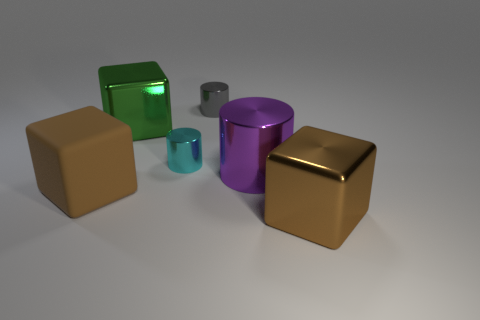Does the rubber cube have the same color as the big metal block that is to the right of the small gray metal object?
Provide a succinct answer. Yes. There is a tiny object in front of the big metallic cube that is to the left of the large brown block to the right of the gray metallic cylinder; what color is it?
Ensure brevity in your answer.  Cyan. Are there fewer big things that are in front of the large metallic cylinder than large brown cubes behind the brown rubber block?
Ensure brevity in your answer.  No. Is the shape of the green object the same as the large brown metal object?
Your answer should be compact. Yes. How many other objects are the same size as the purple shiny object?
Offer a very short reply. 3. Are there fewer tiny gray shiny cylinders that are in front of the purple thing than large matte objects?
Offer a terse response. Yes. What is the size of the green object that is to the left of the metallic cylinder behind the green shiny thing?
Your response must be concise. Large. How many things are either green blocks or big shiny objects?
Your answer should be very brief. 3. Are there any large cubes of the same color as the rubber object?
Offer a terse response. Yes. Is the number of big purple metallic things less than the number of metal blocks?
Provide a succinct answer. Yes. 